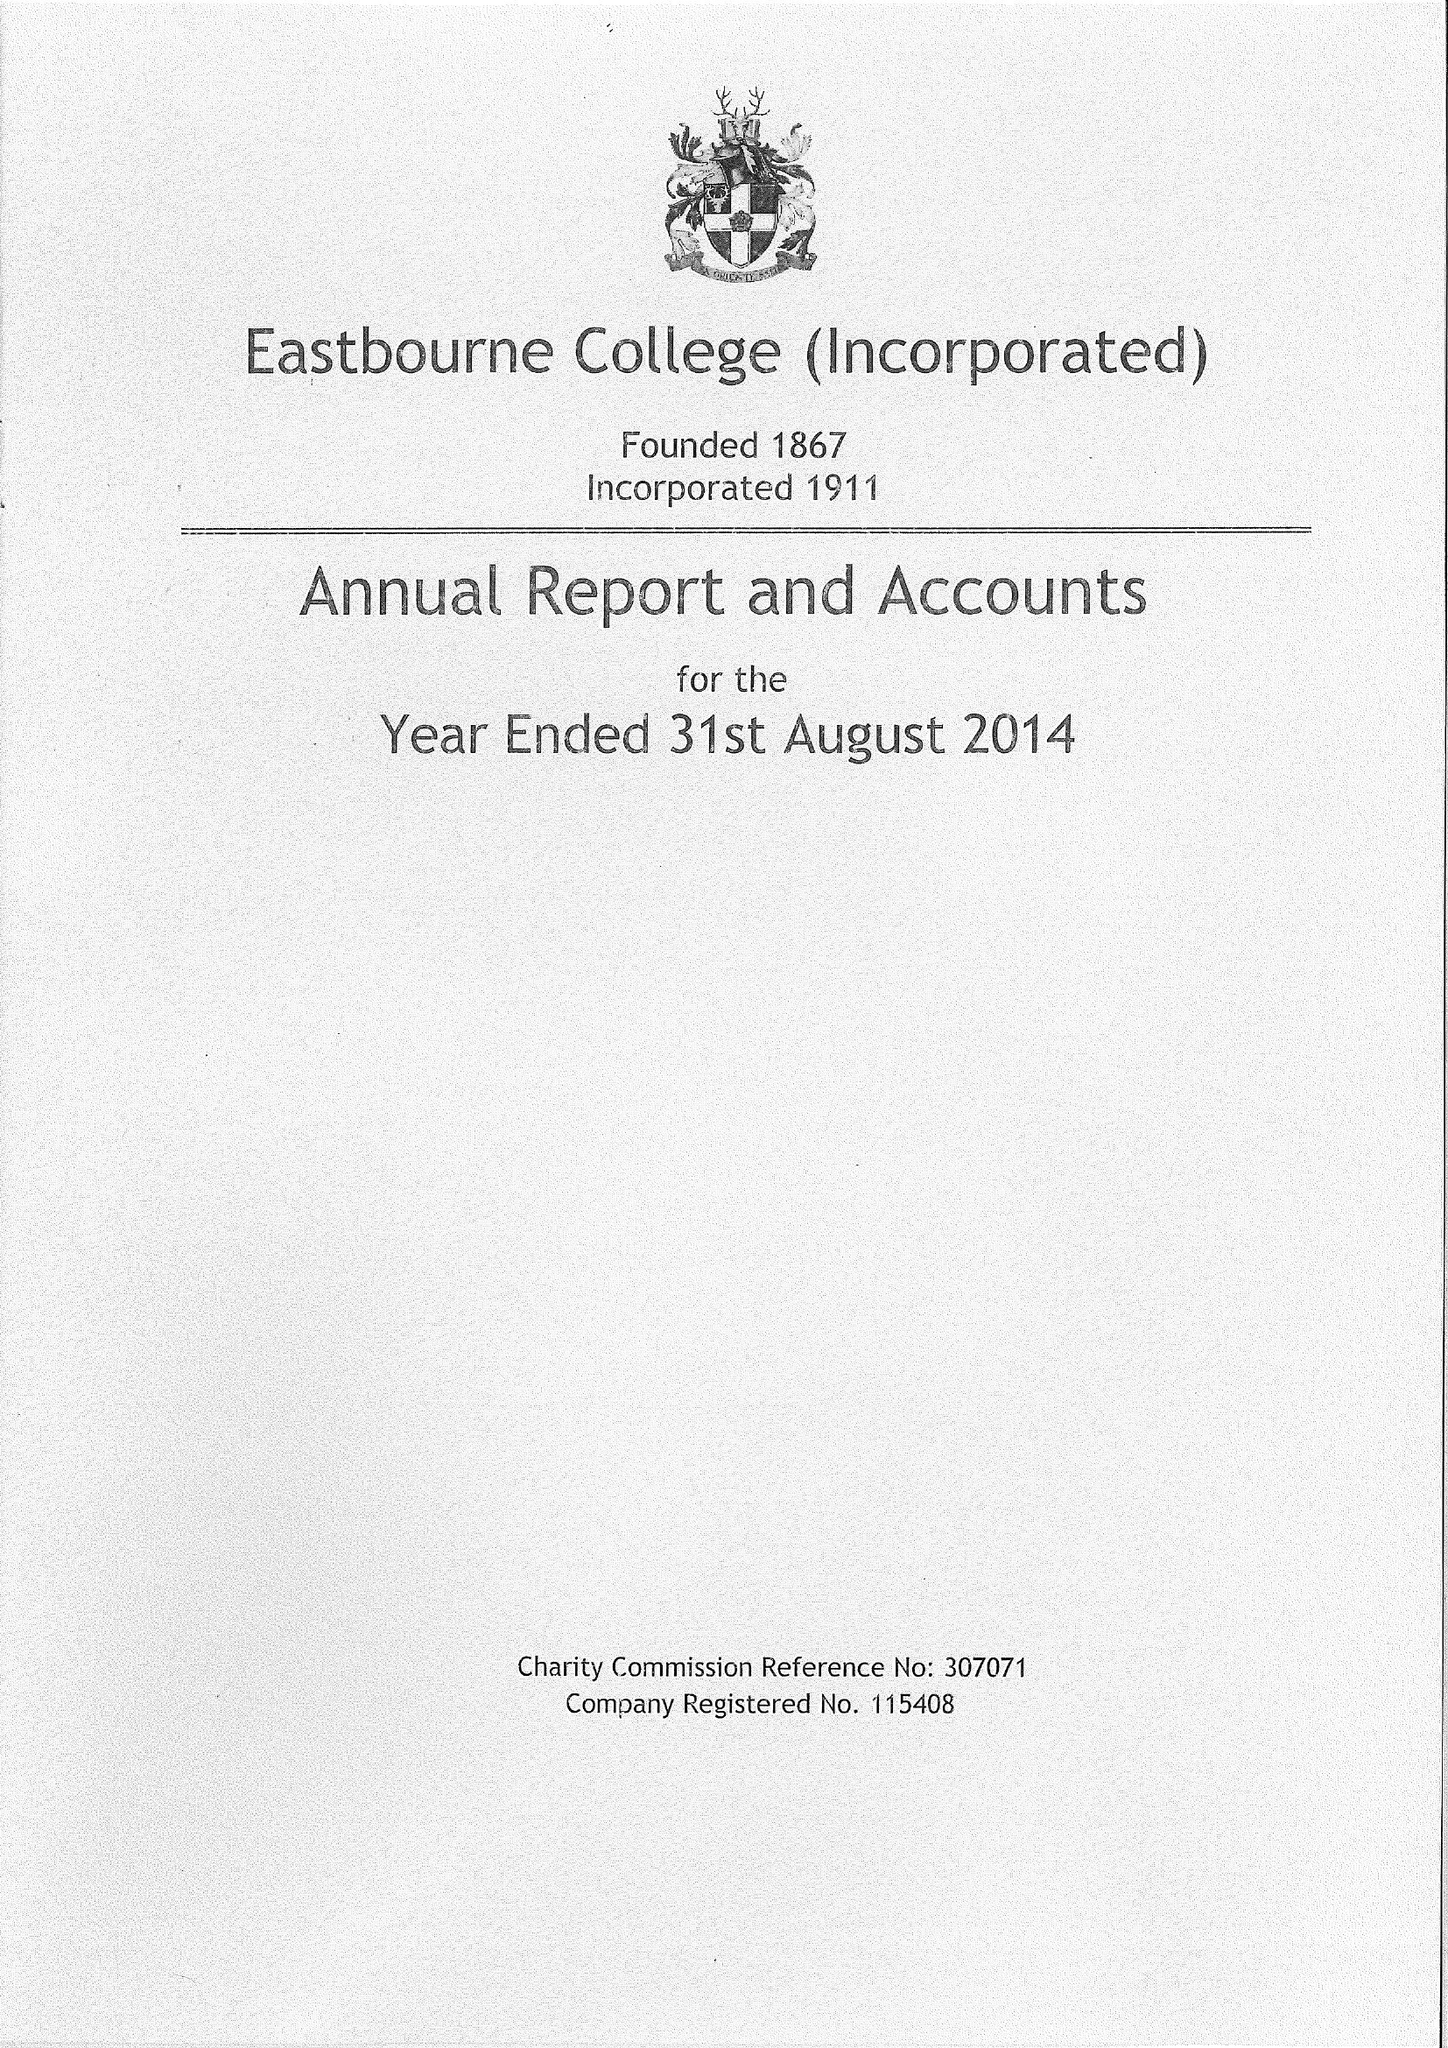What is the value for the report_date?
Answer the question using a single word or phrase. 2014-08-31 